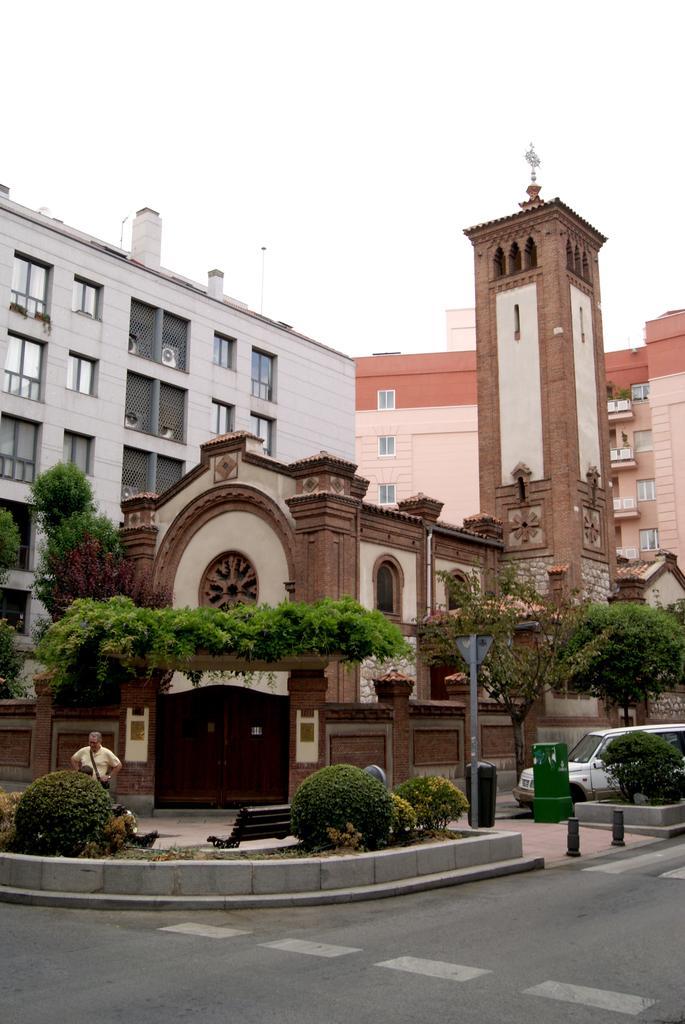Describe this image in one or two sentences. Here in this picture we can see buildings present all over there and on the right side we can see building tower present and in the front we can see plants and trees present all over there and in the middle we can see a gate also present over there and on the right side we can see a van present over there. 